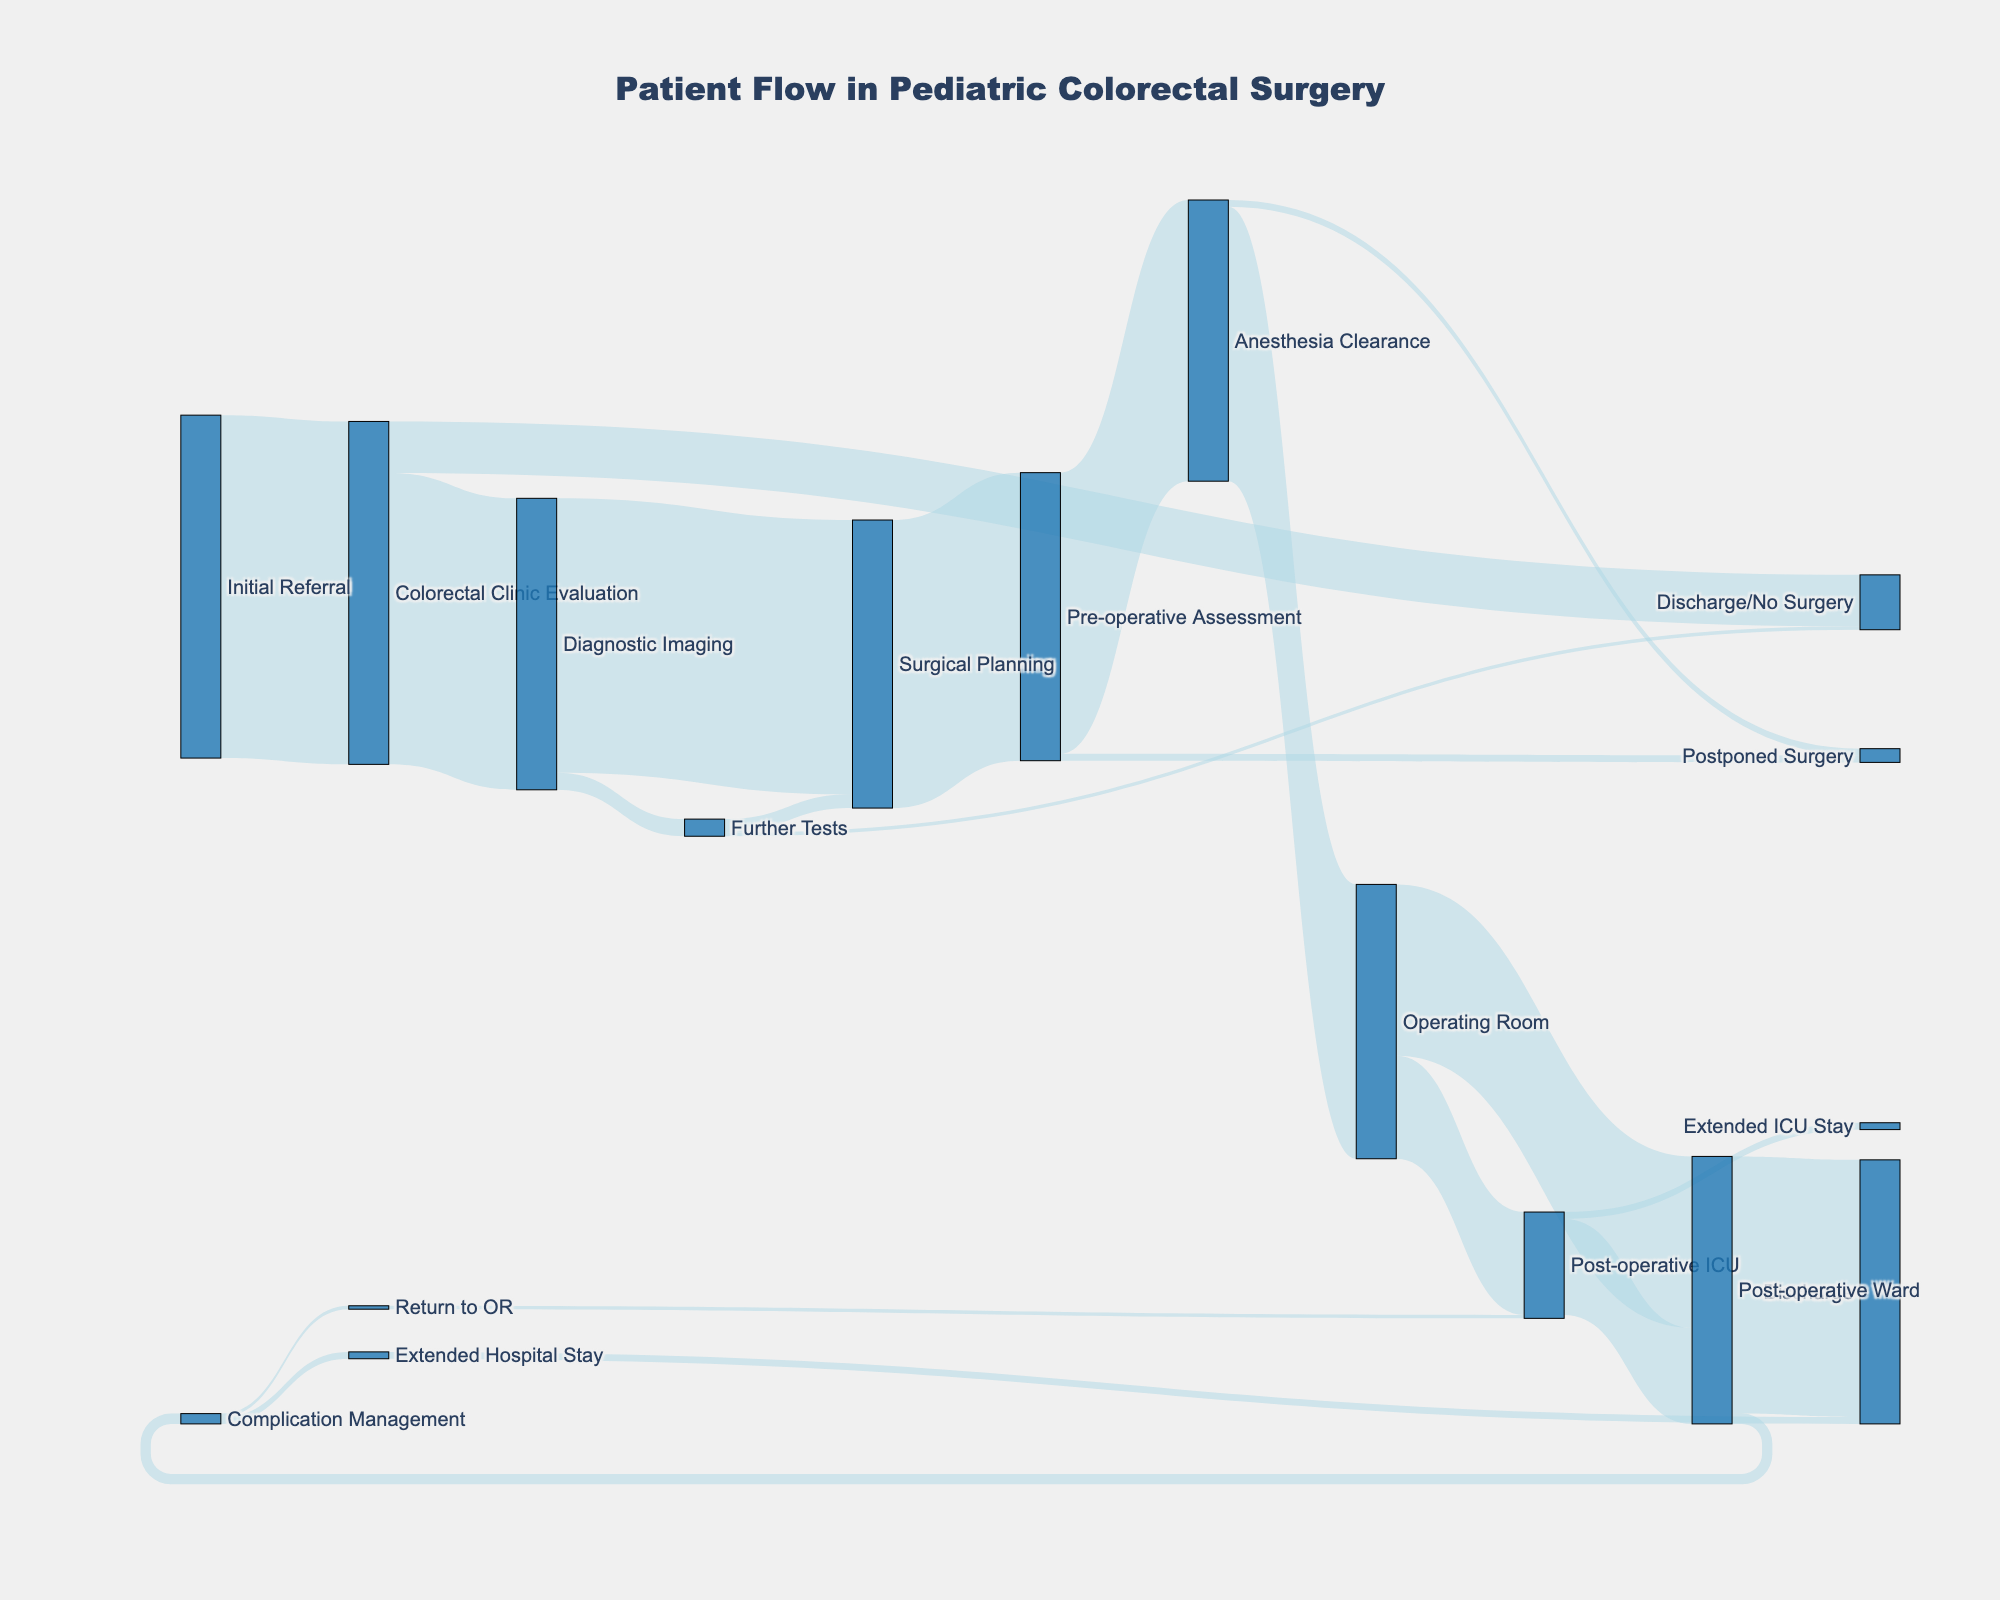What is the title of the figure? The title of the figure is prominently placed at the top center of the diagram.
Answer: Patient Flow in Pediatric Colorectal Surgery How many pathways lead directly from "Colorectal Clinic Evaluation"? The figure shows three links emanating from "Colorectal Clinic Evaluation."
Answer: 3 What's the total number of patients who were discharged without surgery at any stage? Patients discharged without surgery are 15 (from "Colorectal Clinic Evaluation") + 1 (from "Further Tests") = 16.
Answer: 16 What proportion of patients evaluated in the "Colorectal Clinic Evaluation" proceed to "Diagnostic Imaging"? The proportion is found by dividing the number of patients going to "Diagnostic Imaging" (85) by the total evaluated in "Colorectal Clinic Evaluation" (100).
Answer: 85% How many patients needed further tests after "Diagnostic Imaging"? The number of patients proceeding to "Further Tests" from "Diagnostic Imaging" is directly visualized as 5.
Answer: 5 How many patients eventually reach the "Operating Room"? Summing up the paths leading to the Operating Room: 80 (from Anesthesia Clearance).
Answer: 80 What percentage of patients move from "Post-operative Ward" to "Discharge"? The percentage is calculated as (75 / 78) * 100, where 78 is the sum of 75 (Discharge) and 3 (Complication Management).
Answer: 96.15% Which stage causes the most delays or postponements? Summing the values for delays at "Pre-operative Assessment" (2) and "Anesthesia Clearance" (2), both show the same delay count.
Answer: Pre-operative Assessment & Anesthesia Clearance How many patients end up in the "Post-operative ICU" after surgery? Directly seen from the path leading from "Operating Room" to "Post-operative ICU," which shows 30 patients.
Answer: 30 Which stage has the highest dropout rate where patients are no longer part of the primary treatment pathway? The highest dropout rate (no surgery) is seen in "Colorectal Clinic Evaluation" with 15 patients.
Answer: Colorectal Clinic Evaluation 